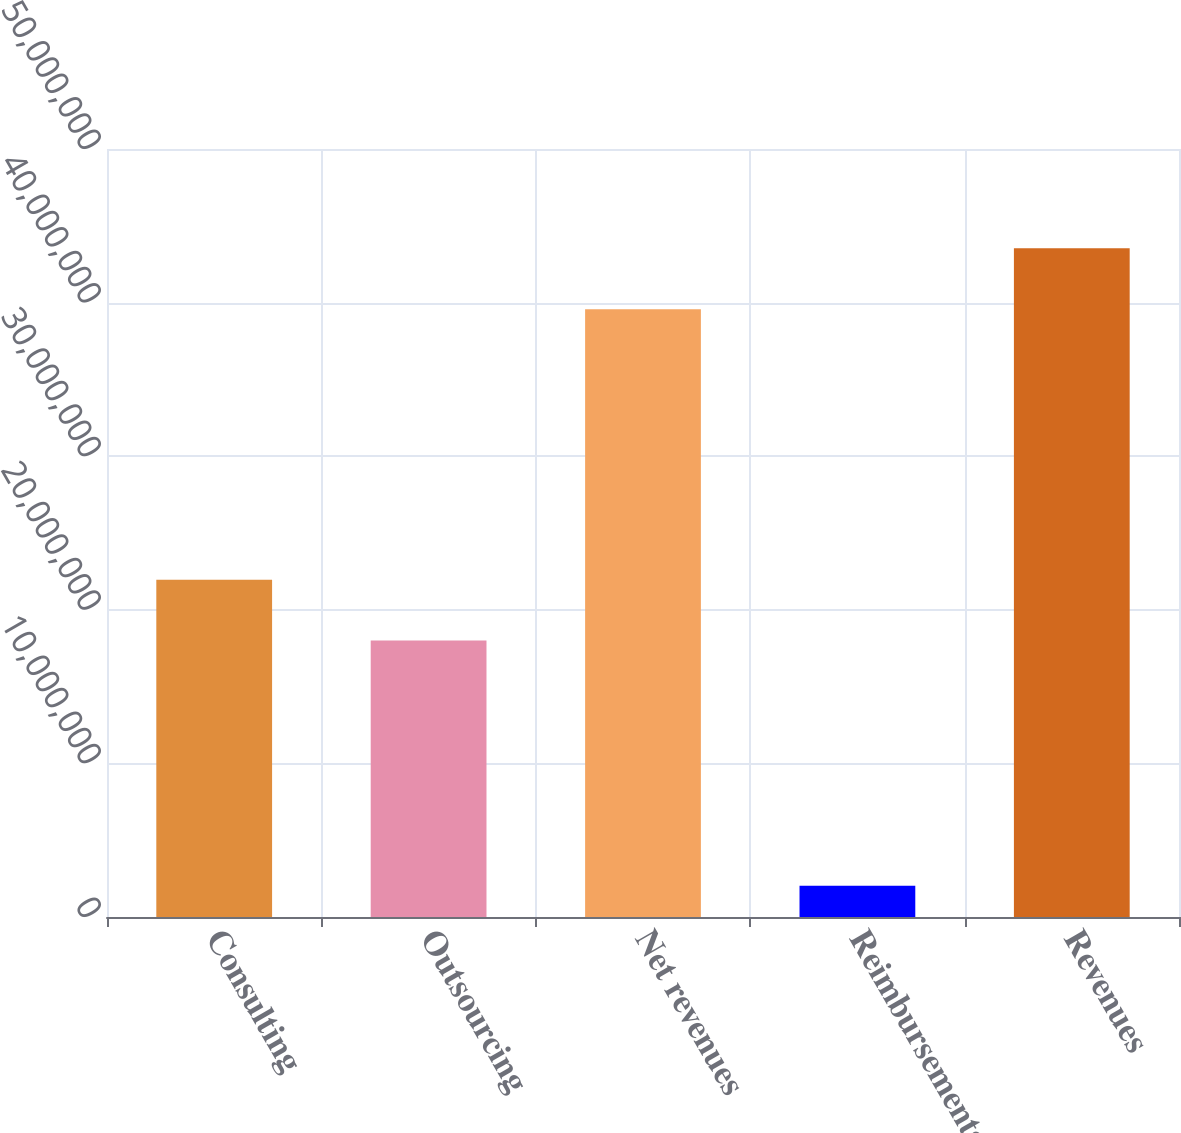Convert chart. <chart><loc_0><loc_0><loc_500><loc_500><bar_chart><fcel>Consulting<fcel>Outsourcing<fcel>Net revenues<fcel>Reimbursements<fcel>Revenues<nl><fcel>2.19568e+07<fcel>1.79995e+07<fcel>3.95734e+07<fcel>2.02998e+06<fcel>4.35308e+07<nl></chart> 